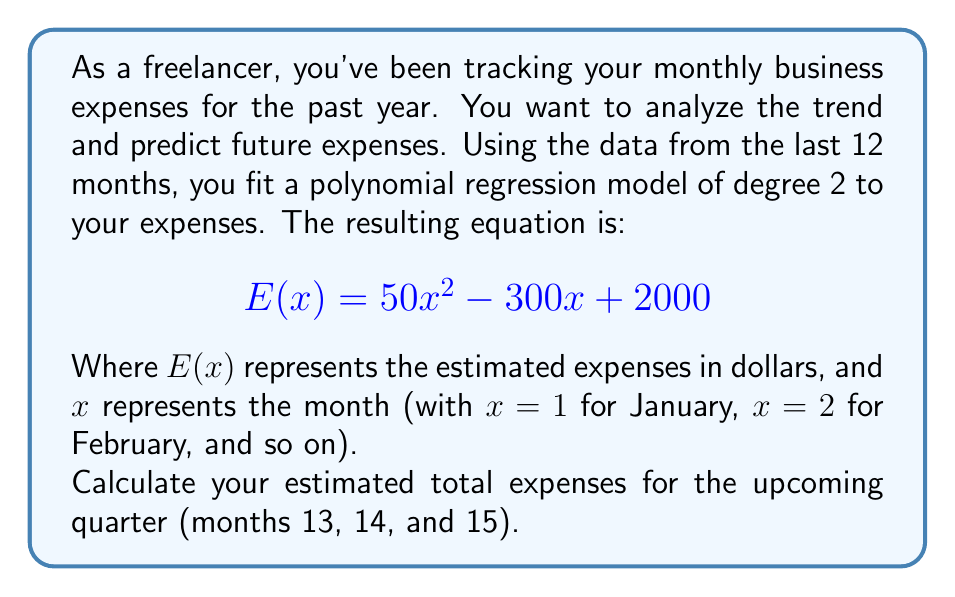Provide a solution to this math problem. To solve this problem, we'll follow these steps:

1. Understand the given polynomial regression equation:
   $$E(x) = 50x^2 - 300x + 2000$$

2. Calculate the expenses for months 13, 14, and 15 using the equation:

   For month 13:
   $$E(13) = 50(13)^2 - 300(13) + 2000$$
   $$= 50(169) - 3900 + 2000$$
   $$= 8450 - 3900 + 2000 = 6550$$

   For month 14:
   $$E(14) = 50(14)^2 - 300(14) + 2000$$
   $$= 50(196) - 4200 + 2000$$
   $$= 9800 - 4200 + 2000 = 7600$$

   For month 15:
   $$E(15) = 50(15)^2 - 300(15) + 2000$$
   $$= 50(225) - 4500 + 2000$$
   $$= 11250 - 4500 + 2000 = 8750$$

3. Sum up the expenses for these three months:
   $$\text{Total} = 6550 + 7600 + 8750 = 22900$$

Therefore, the estimated total expenses for the upcoming quarter (months 13, 14, and 15) is $22,900.
Answer: $22,900 